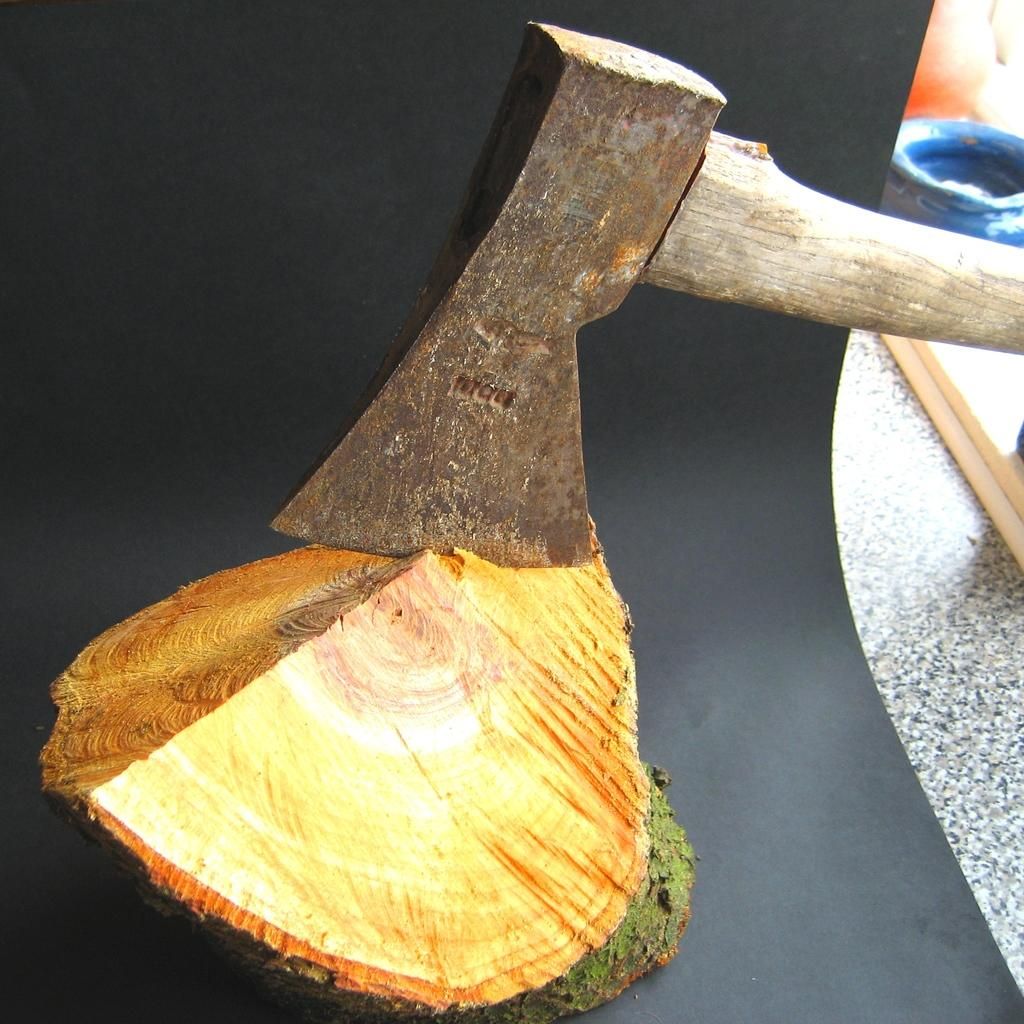What is the main object in the image? There is an axe in the image. What is the axe resting on? The axe is on a wooden log. Can you describe the objects on the right side of the image? Unfortunately, the provided facts do not give any information about the objects on the right side of the image. What type of dime is being used to measure the substance on the wooden log? There is no dime or substance present in the image; it only features an axe on a wooden log. 